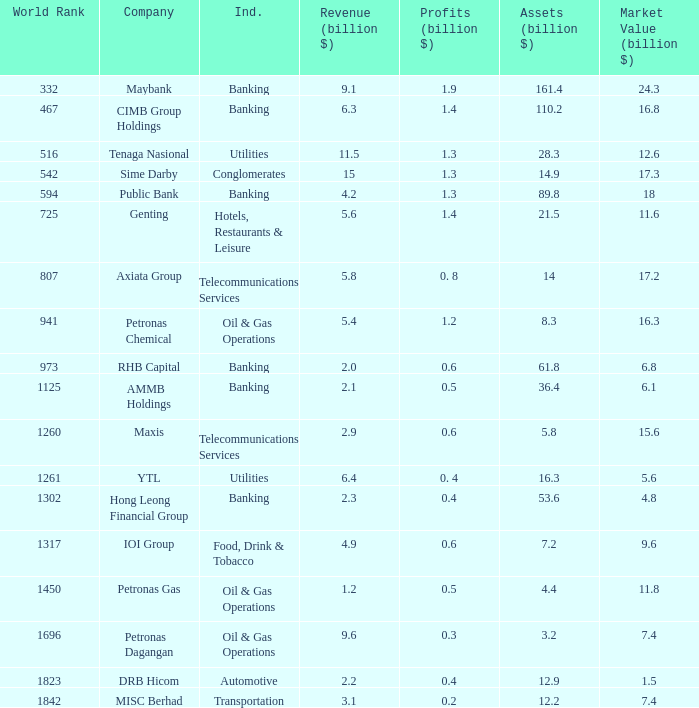Name the total number of industry for maxis 1.0. Parse the table in full. {'header': ['World Rank', 'Company', 'Ind.', 'Revenue (billion $)', 'Profits (billion $)', 'Assets (billion $)', 'Market Value (billion $)'], 'rows': [['332', 'Maybank', 'Banking', '9.1', '1.9', '161.4', '24.3'], ['467', 'CIMB Group Holdings', 'Banking', '6.3', '1.4', '110.2', '16.8'], ['516', 'Tenaga Nasional', 'Utilities', '11.5', '1.3', '28.3', '12.6'], ['542', 'Sime Darby', 'Conglomerates', '15', '1.3', '14.9', '17.3'], ['594', 'Public Bank', 'Banking', '4.2', '1.3', '89.8', '18'], ['725', 'Genting', 'Hotels, Restaurants & Leisure', '5.6', '1.4', '21.5', '11.6'], ['807', 'Axiata Group', 'Telecommunications Services', '5.8', '0. 8', '14', '17.2'], ['941', 'Petronas Chemical', 'Oil & Gas Operations', '5.4', '1.2', '8.3', '16.3'], ['973', 'RHB Capital', 'Banking', '2.0', '0.6', '61.8', '6.8'], ['1125', 'AMMB Holdings', 'Banking', '2.1', '0.5', '36.4', '6.1'], ['1260', 'Maxis', 'Telecommunications Services', '2.9', '0.6', '5.8', '15.6'], ['1261', 'YTL', 'Utilities', '6.4', '0. 4', '16.3', '5.6'], ['1302', 'Hong Leong Financial Group', 'Banking', '2.3', '0.4', '53.6', '4.8'], ['1317', 'IOI Group', 'Food, Drink & Tobacco', '4.9', '0.6', '7.2', '9.6'], ['1450', 'Petronas Gas', 'Oil & Gas Operations', '1.2', '0.5', '4.4', '11.8'], ['1696', 'Petronas Dagangan', 'Oil & Gas Operations', '9.6', '0.3', '3.2', '7.4'], ['1823', 'DRB Hicom', 'Automotive', '2.2', '0.4', '12.9', '1.5'], ['1842', 'MISC Berhad', 'Transportation', '3.1', '0.2', '12.2', '7.4']]} 